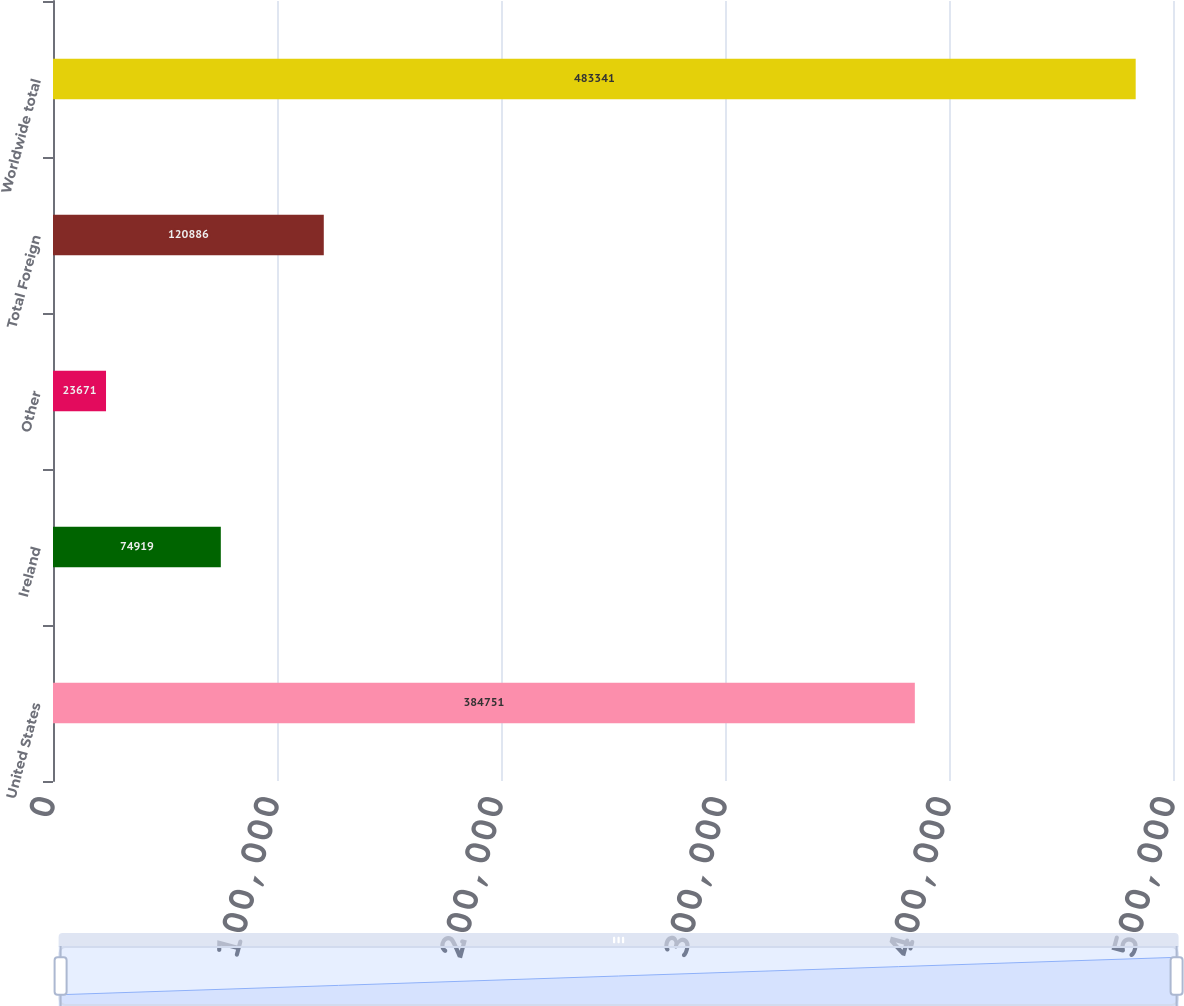Convert chart to OTSL. <chart><loc_0><loc_0><loc_500><loc_500><bar_chart><fcel>United States<fcel>Ireland<fcel>Other<fcel>Total Foreign<fcel>Worldwide total<nl><fcel>384751<fcel>74919<fcel>23671<fcel>120886<fcel>483341<nl></chart> 